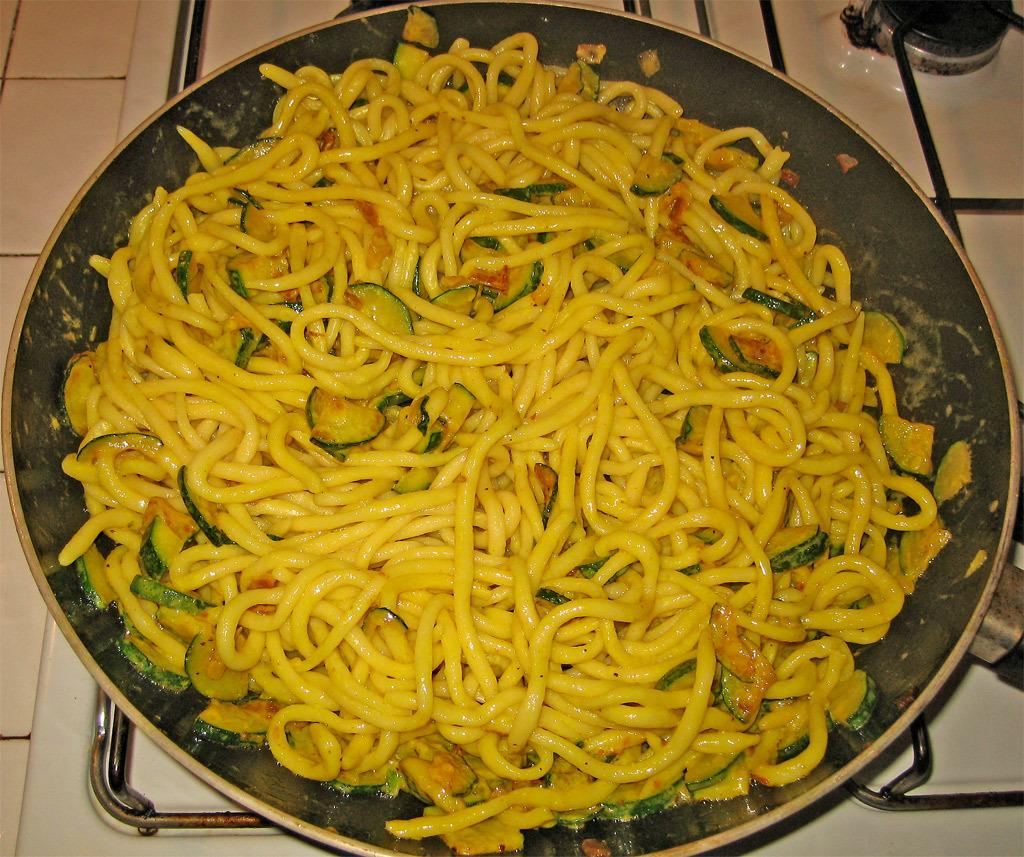What is on the stove in the image? There is a pan on the stove in the image. What is inside the pan? There are noodles in the pan. What color is the ink on the baseball in the image? There is no baseball or ink present in the image. The image only shows a pan with noodles on the stove. 